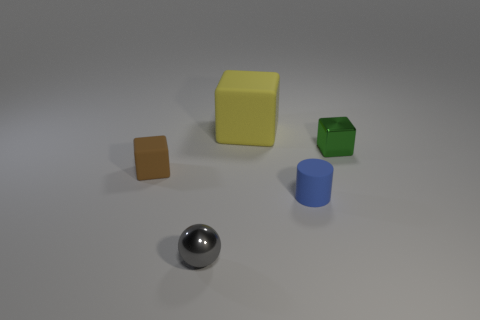Can you tell me about the colors of the objects in the image? Certainly! There are several objects with distinct colors in the image. Starting from the left, there's a small orange square block, followed by a larger, pale yellow cube. In the middle, there's a green cube with a visible shadow indicating it might be hollow or concave on one side. To the right, there's a cylindrical blue object. On the foreground is a shiny, chrome-like spherical object that reflects the environment. 
Do these objects appear to be arranged in a specific pattern or randomly? The arrangement of the objects seems to be random rather than following a specific pattern. They are placed at varying distances from each other, without an obvious sequence or alignment that would suggest a deliberate pattern. 